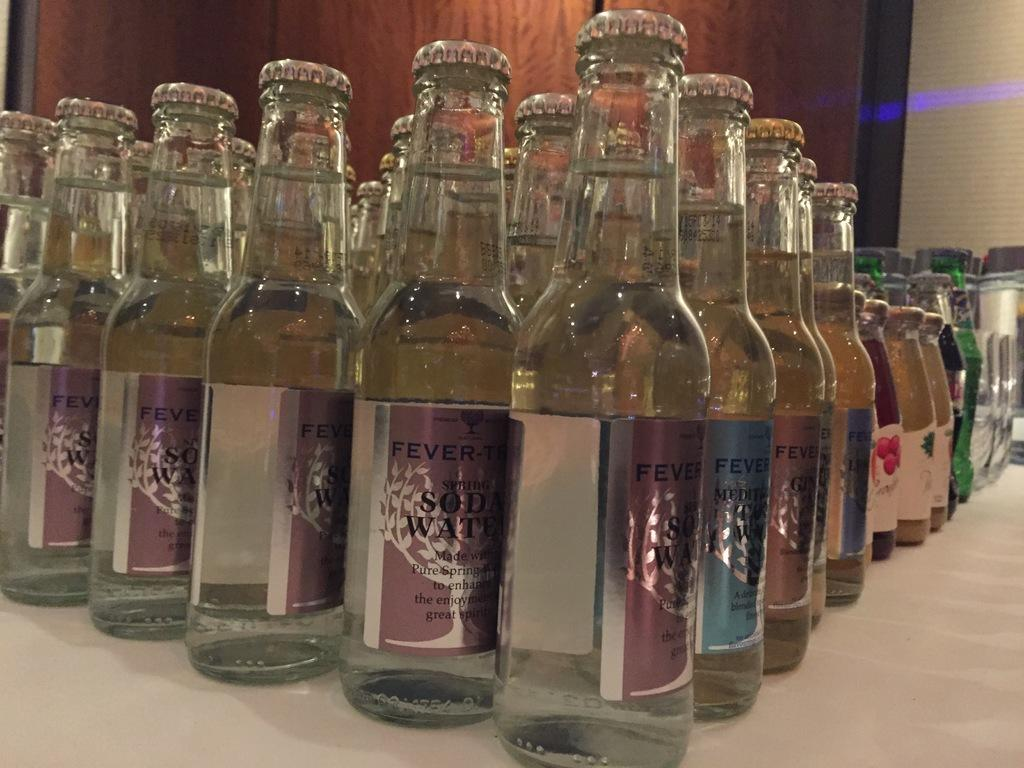<image>
Relay a brief, clear account of the picture shown. Bottles of SODA WATER are arranged neatly into rows on a white shelf. 